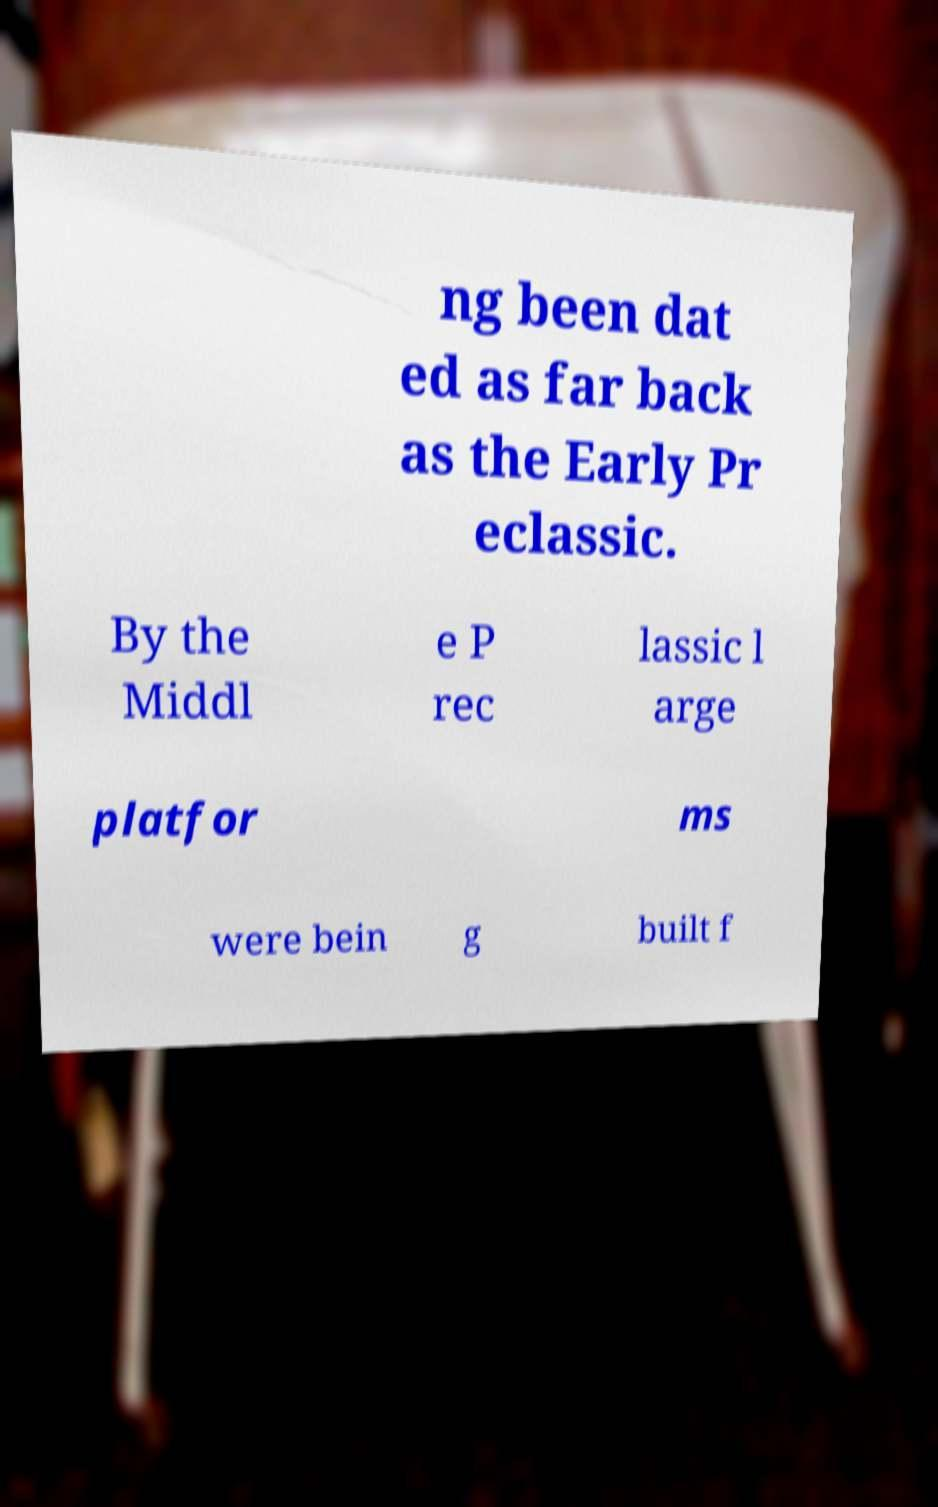Please identify and transcribe the text found in this image. ng been dat ed as far back as the Early Pr eclassic. By the Middl e P rec lassic l arge platfor ms were bein g built f 